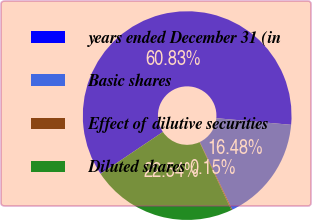<chart> <loc_0><loc_0><loc_500><loc_500><pie_chart><fcel>years ended December 31 (in<fcel>Basic shares<fcel>Effect of dilutive securities<fcel>Diluted shares<nl><fcel>60.83%<fcel>16.48%<fcel>0.15%<fcel>22.54%<nl></chart> 